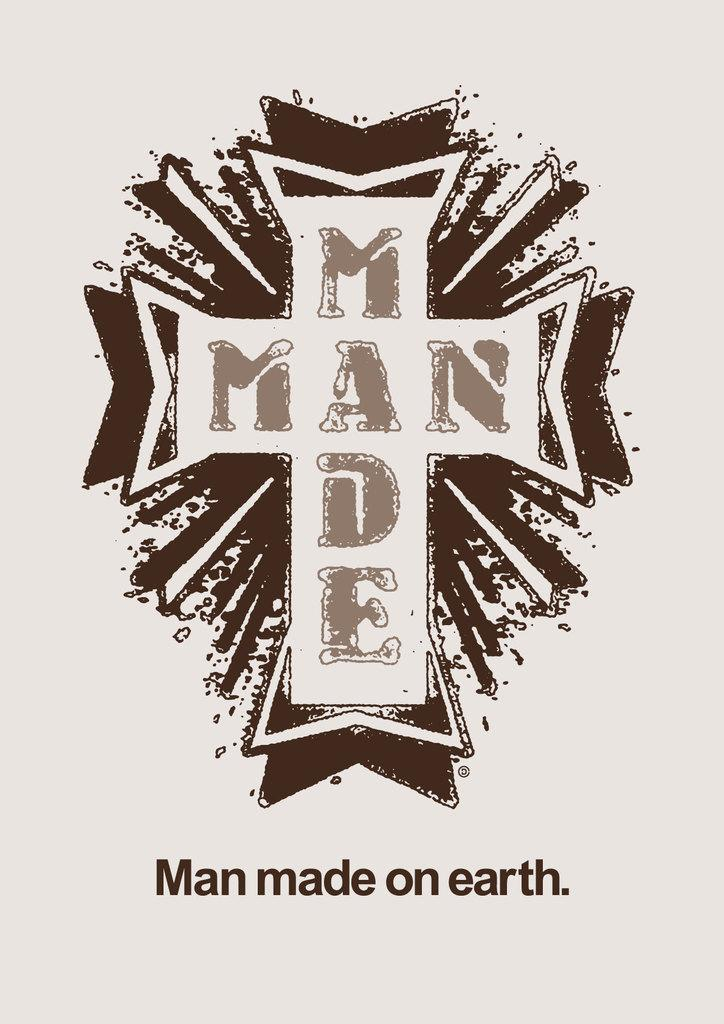<image>
Render a clear and concise summary of the photo. A cross that says Man Made on it. 